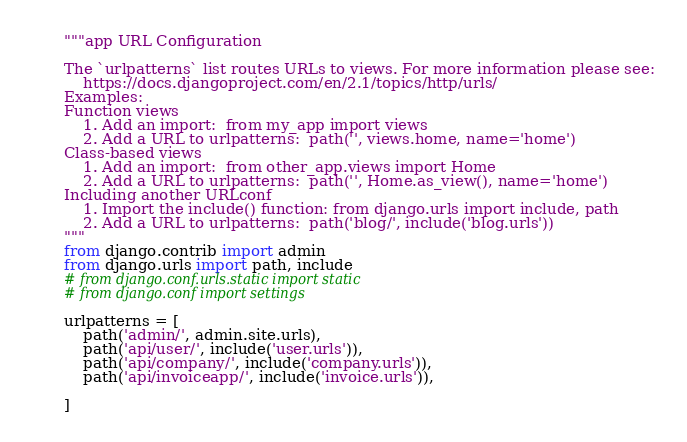<code> <loc_0><loc_0><loc_500><loc_500><_Python_>"""app URL Configuration

The `urlpatterns` list routes URLs to views. For more information please see:
    https://docs.djangoproject.com/en/2.1/topics/http/urls/
Examples:
Function views
    1. Add an import:  from my_app import views
    2. Add a URL to urlpatterns:  path('', views.home, name='home')
Class-based views
    1. Add an import:  from other_app.views import Home
    2. Add a URL to urlpatterns:  path('', Home.as_view(), name='home')
Including another URLconf
    1. Import the include() function: from django.urls import include, path
    2. Add a URL to urlpatterns:  path('blog/', include('blog.urls'))
"""
from django.contrib import admin
from django.urls import path, include
# from django.conf.urls.static import static
# from django.conf import settings

urlpatterns = [
    path('admin/', admin.site.urls),
    path('api/user/', include('user.urls')),
    path('api/company/', include('company.urls')),
    path('api/invoiceapp/', include('invoice.urls')),

]
</code> 